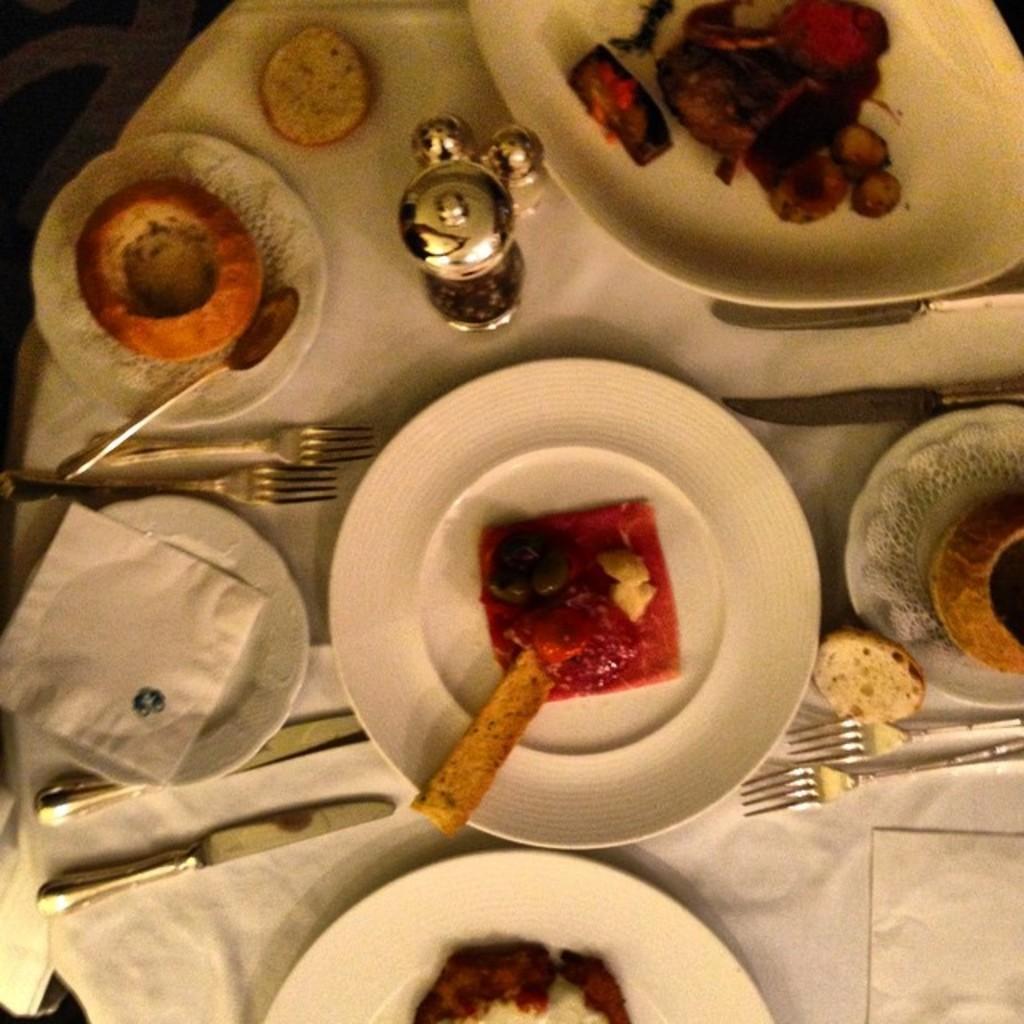In one or two sentences, can you explain what this image depicts? In this image, we can see there are food items arranged on the white color plates, a paper on a white color plate, there are forks, knives, and white color paper and an object. These items are arranged on a table which is covered with a white color paper. And the background is dark in color. 